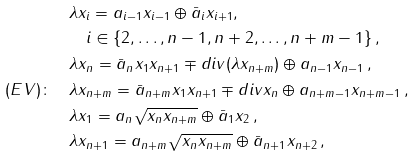<formula> <loc_0><loc_0><loc_500><loc_500>& \lambda x _ { i } = a _ { i - 1 } x _ { i - 1 } \oplus \bar { a } _ { i } x _ { i + 1 } , \, \\ & \quad i \in \{ 2 , \dots , n - 1 , n + 2 , \dots , n + m - 1 \} \, , \\ & \lambda x _ { n } = \bar { a } _ { n } x _ { 1 } x _ { n + 1 } \mp d i v ( \lambda x _ { n + m } ) \oplus a _ { n - 1 } x _ { n - 1 } \, , \\ ( E V ) \colon \quad & \lambda x _ { n + m } = \bar { a } _ { n + m } x _ { 1 } x _ { n + 1 } \mp d i v x _ { n } \oplus a _ { n + m - 1 } x _ { n + m - 1 } \, , \\ & \lambda x _ { 1 } = a _ { n } \sqrt { x _ { n } x _ { n + m } } \oplus \bar { a } _ { 1 } x _ { 2 } \, , \\ & \lambda x _ { n + 1 } = a _ { n + m } \sqrt { x _ { n } x _ { n + m } } \oplus \bar { a } _ { n + 1 } x _ { n + 2 } \, ,</formula> 